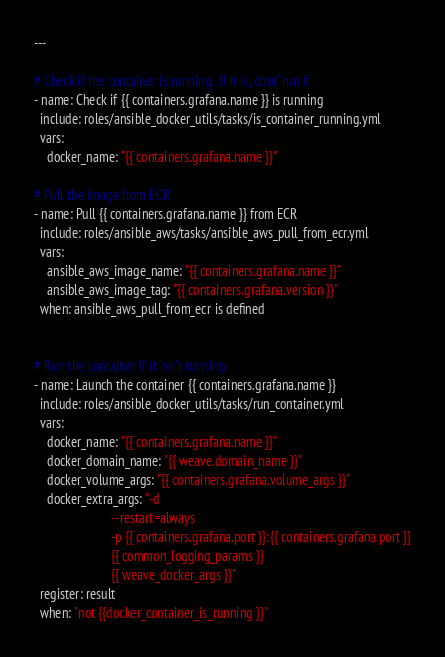Convert code to text. <code><loc_0><loc_0><loc_500><loc_500><_YAML_>---

# Check if the container is running.  If it is, dont' run it
- name: Check if {{ containers.grafana.name }} is running
  include: roles/ansible_docker_utils/tasks/is_container_running.yml
  vars:
    docker_name: "{{ containers.grafana.name }}"

# Pull the image from ECR
- name: Pull {{ containers.grafana.name }} from ECR
  include: roles/ansible_aws/tasks/ansible_aws_pull_from_ecr.yml
  vars:
    ansible_aws_image_name: "{{ containers.grafana.name }}"
    ansible_aws_image_tag: "{{ containers.grafana.version }}"
  when: ansible_aws_pull_from_ecr is defined


# Run the container if it isn't running
- name: Launch the container {{ containers.grafana.name }}
  include: roles/ansible_docker_utils/tasks/run_container.yml
  vars:
    docker_name: "{{ containers.grafana.name }}"
    docker_domain_name: "{{ weave.domain_name }}"
    docker_volume_args: "{{ containers.grafana.volume_args }}"
    docker_extra_args: "-d
                        --restart=always
                        -p {{ containers.grafana.port }}:{{ containers.grafana.port }}
                        {{ common_logging_params }}
                        {{ weave_docker_args }}"
  register: result
  when: "not {{docker_container_is_running }}"
</code> 